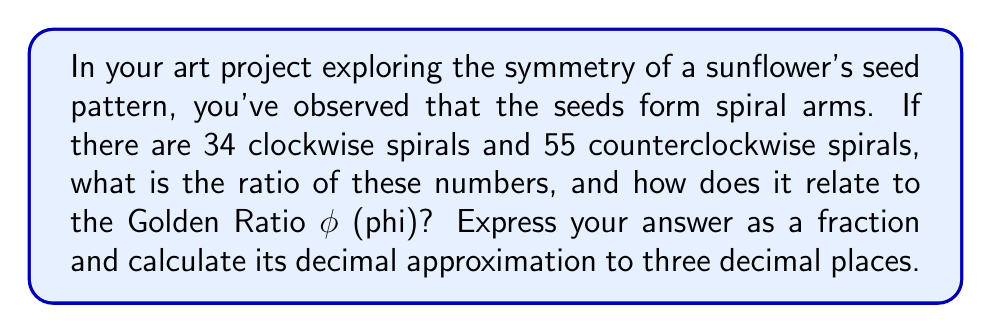Can you answer this question? Let's approach this step-by-step:

1) First, we need to form the ratio of the number of clockwise spirals to counterclockwise spirals:

   $\frac{34}{55}$

2) This ratio is interesting because 34 and 55 are consecutive Fibonacci numbers. The Fibonacci sequence is closely related to the Golden Ratio.

3) The Golden Ratio, $\phi$, is approximately equal to 1.618034...

4) As we move along the Fibonacci sequence, the ratio of consecutive terms gets closer and closer to $\frac{1}{\phi}$.

5) To see how close our ratio is to $\frac{1}{\phi}$, let's calculate its decimal approximation:

   $\frac{34}{55} \approx 0.618181...$

6) Now, let's calculate $\frac{1}{\phi}$:

   $\frac{1}{\phi} \approx \frac{1}{1.618034} \approx 0.618034...$

7) We can see that our ratio $\frac{34}{55}$ is very close to $\frac{1}{\phi}$.

8) To express this to three decimal places, we round 0.618181... to 0.618.

Therefore, the ratio $\frac{34}{55}$ ≈ 0.618, which is remarkably close to $\frac{1}{\phi}$, demonstrating the Golden Ratio's presence in this natural pattern.
Answer: $\frac{34}{55}$, 0.618 